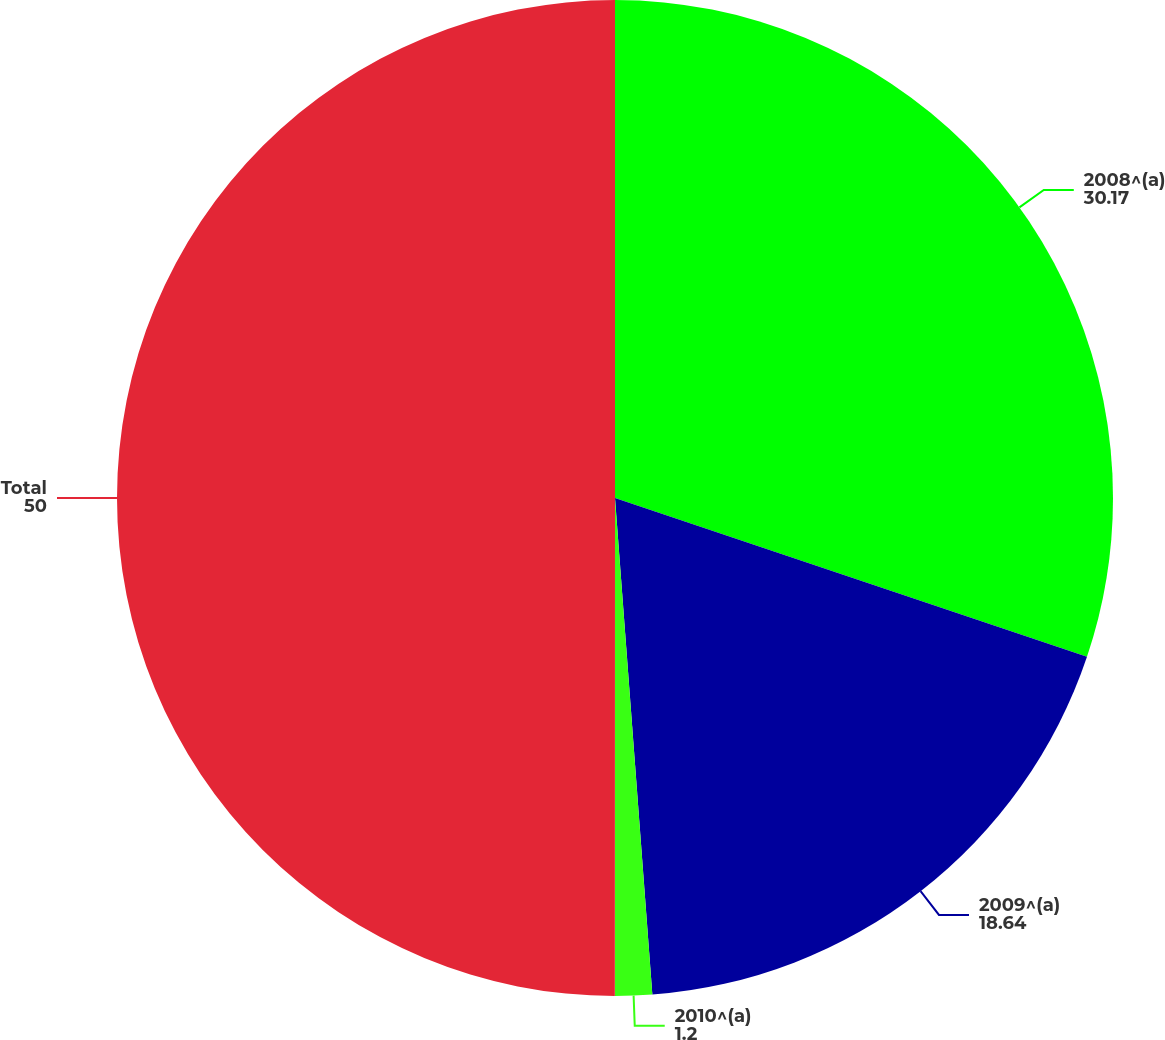Convert chart to OTSL. <chart><loc_0><loc_0><loc_500><loc_500><pie_chart><fcel>2008^(a)<fcel>2009^(a)<fcel>2010^(a)<fcel>Total<nl><fcel>30.17%<fcel>18.64%<fcel>1.2%<fcel>50.0%<nl></chart> 